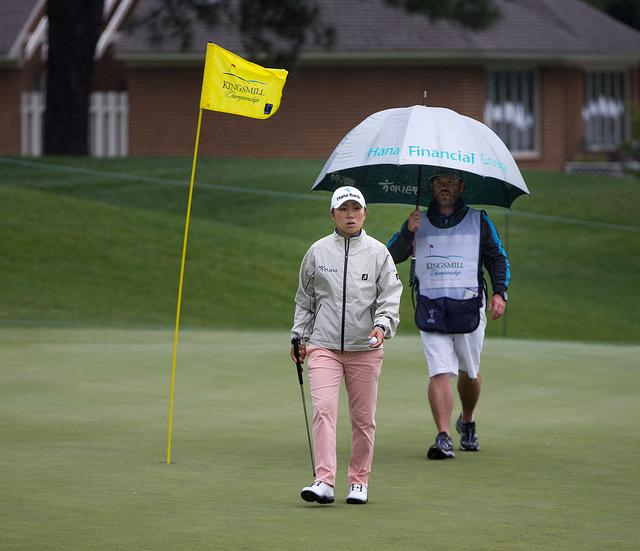What are they doing? Please explain your reasoning. golfing. They are all golfing on the green. 